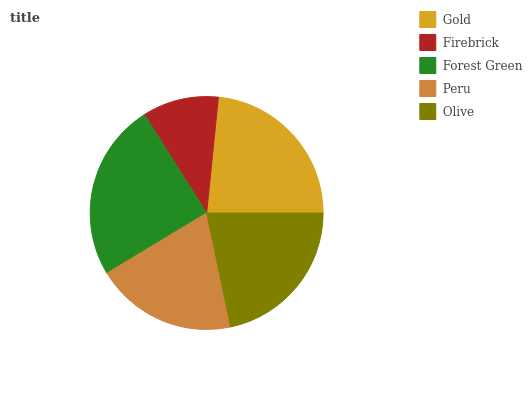Is Firebrick the minimum?
Answer yes or no. Yes. Is Forest Green the maximum?
Answer yes or no. Yes. Is Forest Green the minimum?
Answer yes or no. No. Is Firebrick the maximum?
Answer yes or no. No. Is Forest Green greater than Firebrick?
Answer yes or no. Yes. Is Firebrick less than Forest Green?
Answer yes or no. Yes. Is Firebrick greater than Forest Green?
Answer yes or no. No. Is Forest Green less than Firebrick?
Answer yes or no. No. Is Olive the high median?
Answer yes or no. Yes. Is Olive the low median?
Answer yes or no. Yes. Is Firebrick the high median?
Answer yes or no. No. Is Forest Green the low median?
Answer yes or no. No. 